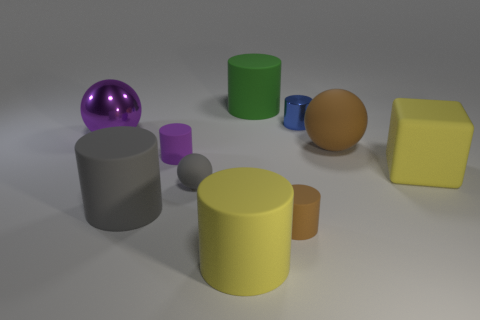How many other things are the same size as the purple metallic thing?
Provide a succinct answer. 5. What number of big things are matte cylinders or brown matte things?
Make the answer very short. 4. Are there more large gray rubber cylinders left of the small gray thing than purple matte objects that are to the right of the large brown thing?
Your answer should be compact. Yes. There is a large object that is in front of the big gray object; is its color the same as the rubber block?
Provide a short and direct response. Yes. Are there any other things that have the same color as the tiny metal thing?
Provide a succinct answer. No. Are there more brown cylinders in front of the blue thing than red metal cubes?
Provide a short and direct response. Yes. Is the blue object the same size as the yellow rubber cylinder?
Your answer should be compact. No. There is a brown object that is the same shape as the small purple object; what is it made of?
Provide a succinct answer. Rubber. Is there anything else that has the same material as the large green cylinder?
Give a very brief answer. Yes. How many blue things are either large rubber balls or small spheres?
Provide a short and direct response. 0. 